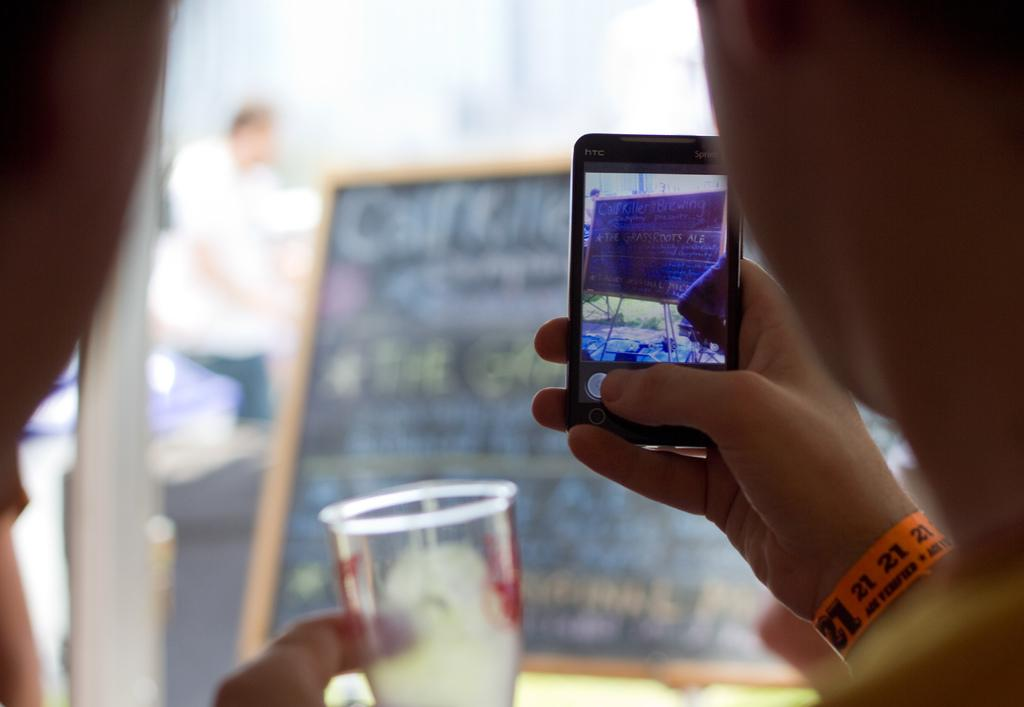<image>
Render a clear and concise summary of the photo. Person wearing an orange wristband that says the number 21 on it. 